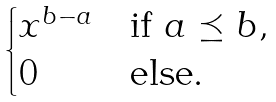Convert formula to latex. <formula><loc_0><loc_0><loc_500><loc_500>\begin{cases} x ^ { b - a } & \text {if } a \preceq b , \\ 0 & \text {else} . \end{cases}</formula> 